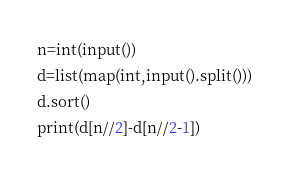<code> <loc_0><loc_0><loc_500><loc_500><_Python_>n=int(input())
d=list(map(int,input().split()))
d.sort()
print(d[n//2]-d[n//2-1])</code> 